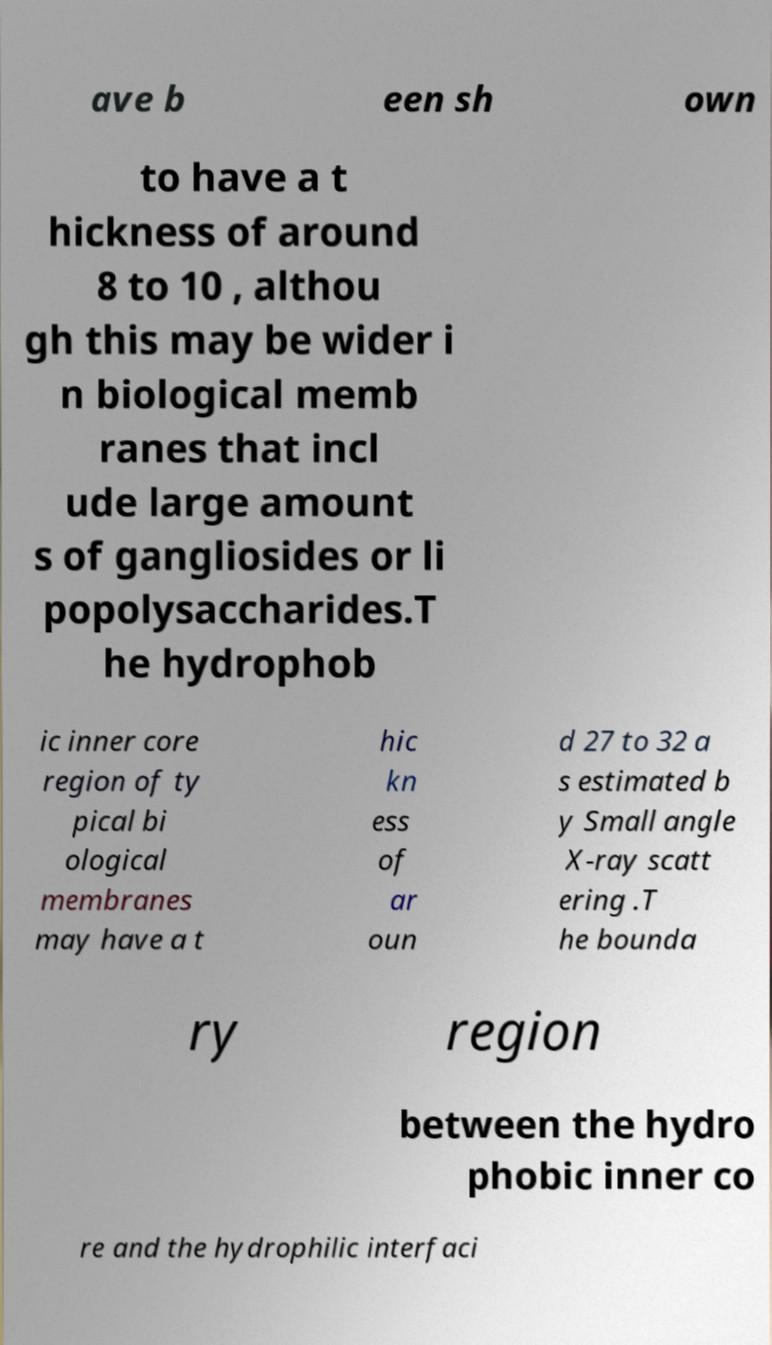I need the written content from this picture converted into text. Can you do that? ave b een sh own to have a t hickness of around 8 to 10 , althou gh this may be wider i n biological memb ranes that incl ude large amount s of gangliosides or li popolysaccharides.T he hydrophob ic inner core region of ty pical bi ological membranes may have a t hic kn ess of ar oun d 27 to 32 a s estimated b y Small angle X-ray scatt ering .T he bounda ry region between the hydro phobic inner co re and the hydrophilic interfaci 